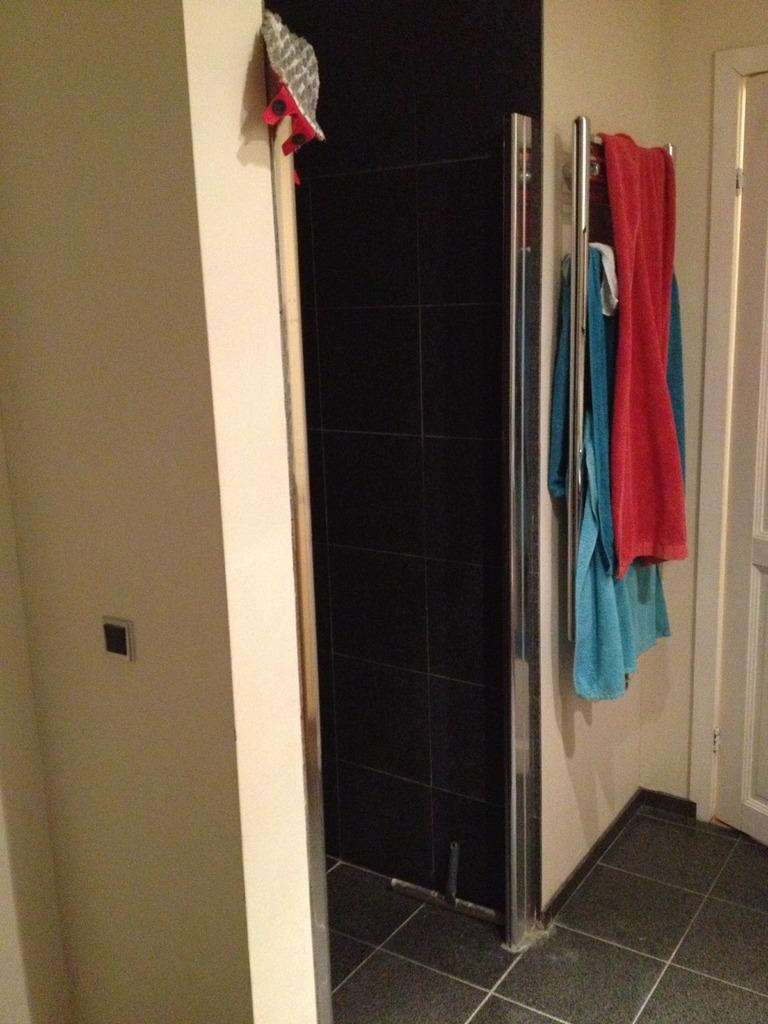How many towels are visible in the image? There are two towels in the image. What colors are the towels? One towel is red in color, and the other towel is blue in color. Where are the towels located in the image? The towels are placed on a rod. What can be seen in the right corner of the image? There is a door in the right corner of the image. What type of mark can be seen on the earth in the image? There is no reference to the earth or any marks in the image; it only features two towels on a rod and a door in the right corner. 